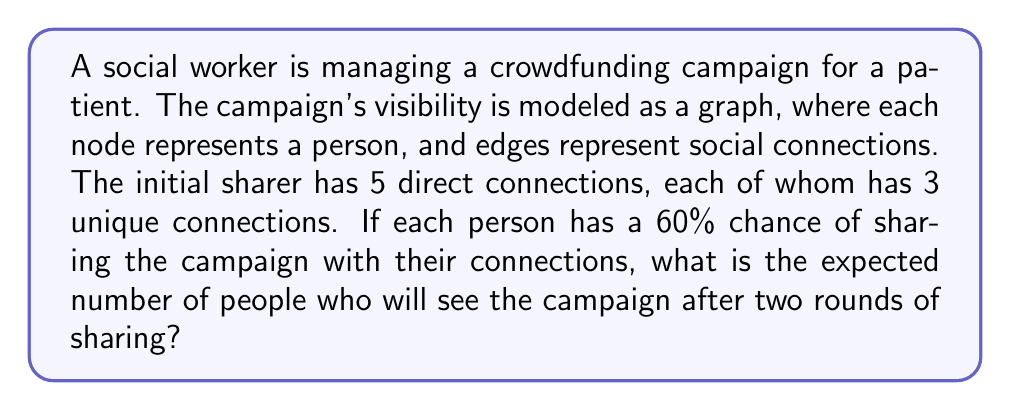Can you answer this question? Let's approach this step-by-step using graph theory and probability:

1) First, let's model the network:
   - Initial sharer (level 0): 1 person
   - First level connections: 5 people
   - Second level connections: 5 * 3 = 15 people

2) Now, let's calculate the probability of the campaign reaching each level:
   
   Level 1: The probability of the initial person sharing is 100% (given)
   $P(\text{reach level 1}) = 1$

   Level 2: For each person in level 1 to see the campaign, the initial person must share it.
   $P(\text{reach level 2}) = 0.6$

3) Expected number of people reached at each level:

   Level 0: 1 person (the initial sharer)

   Level 1: $5 * P(\text{reach level 1}) = 5 * 1 = 5$ people

   Level 2: $15 * P(\text{reach level 2}) = 15 * 0.6 = 9$ people

4) Total expected reach:

   $E(\text{total reach}) = 1 + 5 + 9 = 15$ people

Therefore, the expected number of people who will see the campaign after two rounds of sharing is 15.
Answer: 15 people 